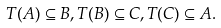<formula> <loc_0><loc_0><loc_500><loc_500>T ( A ) \subseteq B , T ( B ) \subseteq C , T ( C ) \subseteq A .</formula> 